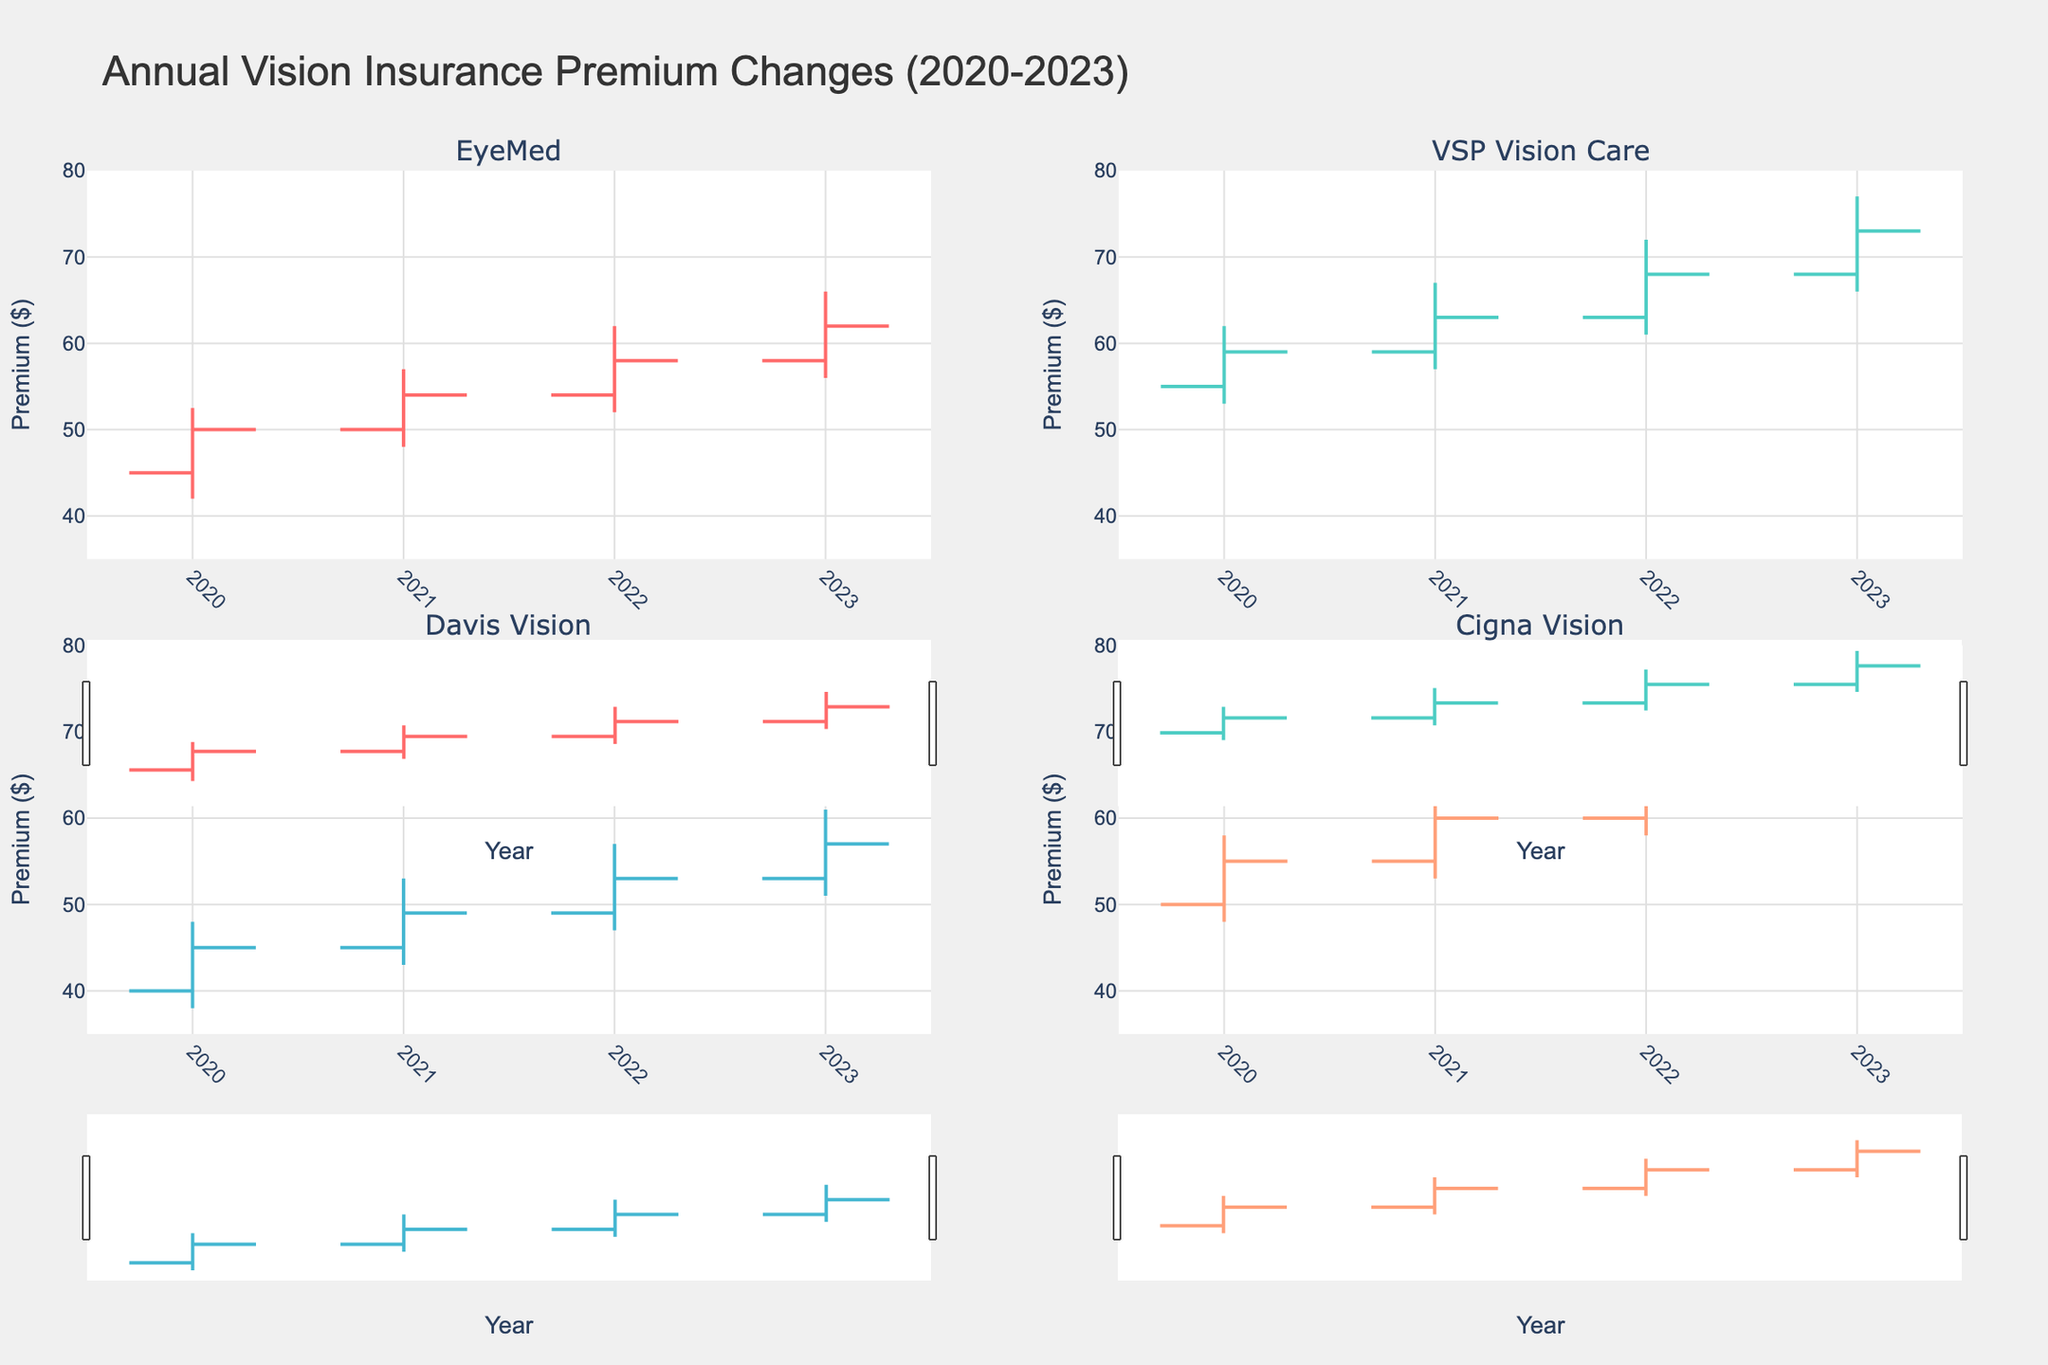What is the title of the figure? The title of the figure is written at the top of the plot. It reads as "Annual Vision Insurance Premium Changes (2020-2023)."
Answer: Annual Vision Insurance Premium Changes (2020-2023) How many providers are compared in the figure? By counting the number of subplot titles, we can see that there are a total of four providers being compared. Each of the four subplots represents one provider.
Answer: Four Which year shows the highest closing premium for "VSP Vision Care"? By examining the closing values in the VSP Vision Care subplot, we find that the highest closing premium is in 2023, where the closing value is 73.00.
Answer: 2023 Between 2020 and 2023, which provider had the most stable range (difference between High and Low) in premiums each year? To determine the most stable provider, we calculate the range (High - Low) for each year and compare averages. "EyeMed" has ranges of 10.5, 9, 10, and 10, respectively, averaging 9.9; "VSP Vision Care' has ranges of 9, 10, 11, and 11, averaging 10.25; "Davis Vision" has ranges of 10, 10, 10, and 10, averaging 10; and "Cigna Vision" has ranges of 10, 10, 10, and 10, averaging 10. "EyeMed" has the lowest average range, thus being the most stable.
Answer: EyeMed Which provider had the earliest shift from an increasing to a decreasing premium trend between years? By comparing the closing values year-to-year for each provider, EyeMed shows the trend shift earliest from an increasing trend (2020 to 2021) to a decreasing trend (2022 and 2023).
Answer: EyeMed What’s the average of the closing premiums for "Davis Vision" from 2020 to 2023? To find the average closing premium for Davis Vision, we add the closing values for each year: 45 (2020), 49 (2021), 53 (2022), and 57 (2023). The sum is 204. Dividing by 4 years gives 204 / 4 = 51.
Answer: 51 For which provider did the premium increase the most from the opening to closing value in a single year, and what was the amount? By comparing the difference between opening and closing premiums for each provider-year pair, "VSP Vision Care" in 2021 shows the largest increase: 63 (close) - 59 (open) = 4.
Answer: VSP Vision Care, 4 In which year did "Cigna Vision" experience the smallest gap between the highest and lowest premium? By calculating the gap (High - Low) for each year in the Cigna Vision subplot, the smallest gap is in 2020 (58 - 48 = 10).
Answer: 2020 Which provider had an increasing premium every consecutive year from 2020 to 2023? By checking the closing premium values year by year, "Cigna Vision" has consistently increasing premiums: 55 (2020), 60 (2021), 65 (2022), and 70 (2023).
Answer: Cigna Vision 